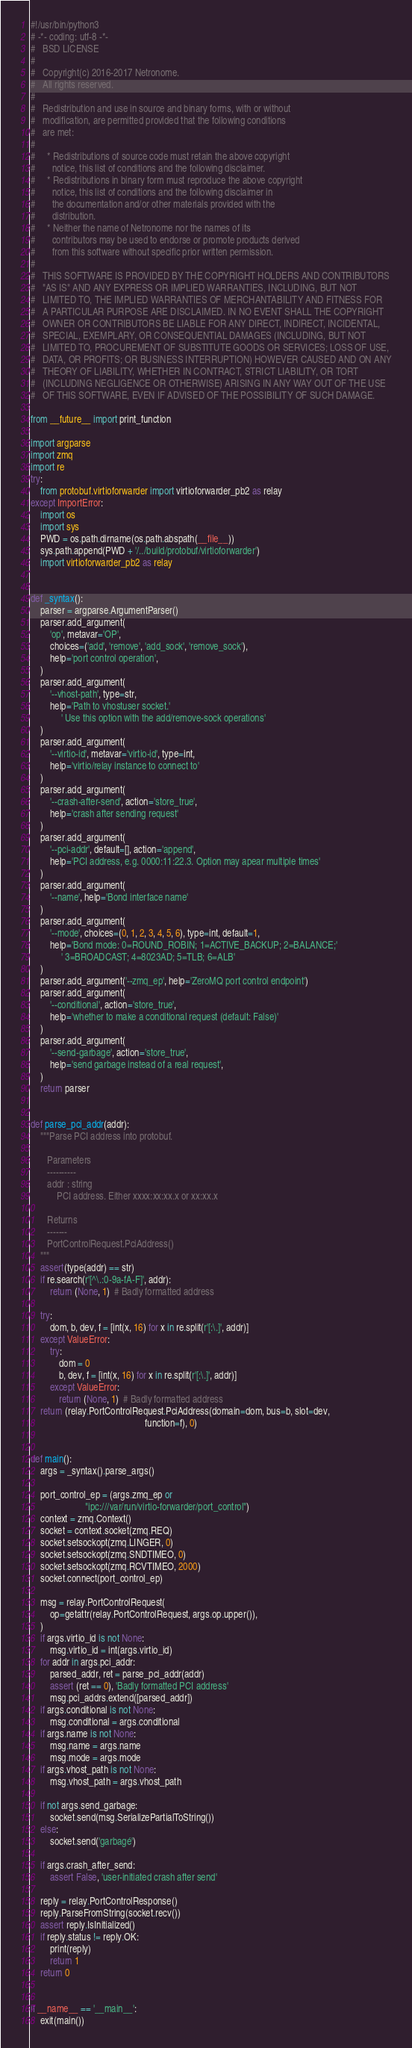Convert code to text. <code><loc_0><loc_0><loc_500><loc_500><_Python_>#!/usr/bin/python3
# -*- coding: utf-8 -*-
#   BSD LICENSE
#
#   Copyright(c) 2016-2017 Netronome.
#   All rights reserved.
#
#   Redistribution and use in source and binary forms, with or without
#   modification, are permitted provided that the following conditions
#   are met:
#
#     * Redistributions of source code must retain the above copyright
#       notice, this list of conditions and the following disclaimer.
#     * Redistributions in binary form must reproduce the above copyright
#       notice, this list of conditions and the following disclaimer in
#       the documentation and/or other materials provided with the
#       distribution.
#     * Neither the name of Netronome nor the names of its
#       contributors may be used to endorse or promote products derived
#       from this software without specific prior written permission.
#
#   THIS SOFTWARE IS PROVIDED BY THE COPYRIGHT HOLDERS AND CONTRIBUTORS
#   "AS IS" AND ANY EXPRESS OR IMPLIED WARRANTIES, INCLUDING, BUT NOT
#   LIMITED TO, THE IMPLIED WARRANTIES OF MERCHANTABILITY AND FITNESS FOR
#   A PARTICULAR PURPOSE ARE DISCLAIMED. IN NO EVENT SHALL THE COPYRIGHT
#   OWNER OR CONTRIBUTORS BE LIABLE FOR ANY DIRECT, INDIRECT, INCIDENTAL,
#   SPECIAL, EXEMPLARY, OR CONSEQUENTIAL DAMAGES (INCLUDING, BUT NOT
#   LIMITED TO, PROCUREMENT OF SUBSTITUTE GOODS OR SERVICES; LOSS OF USE,
#   DATA, OR PROFITS; OR BUSINESS INTERRUPTION) HOWEVER CAUSED AND ON ANY
#   THEORY OF LIABILITY, WHETHER IN CONTRACT, STRICT LIABILITY, OR TORT
#   (INCLUDING NEGLIGENCE OR OTHERWISE) ARISING IN ANY WAY OUT OF THE USE
#   OF THIS SOFTWARE, EVEN IF ADVISED OF THE POSSIBILITY OF SUCH DAMAGE.

from __future__ import print_function

import argparse
import zmq
import re
try:
    from protobuf.virtioforwarder import virtioforwarder_pb2 as relay
except ImportError:
    import os
    import sys
    PWD = os.path.dirname(os.path.abspath(__file__))
    sys.path.append(PWD + '/../build/protobuf/virtioforwarder')
    import virtioforwarder_pb2 as relay


def _syntax():
    parser = argparse.ArgumentParser()
    parser.add_argument(
        'op', metavar='OP',
        choices=('add', 'remove', 'add_sock', 'remove_sock'),
        help='port control operation',
    )
    parser.add_argument(
        '--vhost-path', type=str,
        help='Path to vhostuser socket.'
             ' Use this option with the add/remove-sock operations'
    )
    parser.add_argument(
        '--virtio-id', metavar='virtio-id', type=int,
        help='virtio/relay instance to connect to'
    )
    parser.add_argument(
        '--crash-after-send', action='store_true',
        help='crash after sending request'
    )
    parser.add_argument(
        '--pci-addr', default=[], action='append',
        help='PCI address, e.g. 0000:11:22.3. Option may apear multiple times'
    )
    parser.add_argument(
        '--name', help='Bond interface name'
    )
    parser.add_argument(
        '--mode', choices=(0, 1, 2, 3, 4, 5, 6), type=int, default=1,
        help='Bond mode: 0=ROUND_ROBIN; 1=ACTIVE_BACKUP; 2=BALANCE;'
             ' 3=BROADCAST; 4=8023AD; 5=TLB; 6=ALB'
    )
    parser.add_argument('--zmq_ep', help='ZeroMQ port control endpoint')
    parser.add_argument(
        '--conditional', action='store_true',
        help='whether to make a conditional request (default: False)'
    )
    parser.add_argument(
        '--send-garbage', action='store_true',
        help='send garbage instead of a real request',
    )
    return parser


def parse_pci_addr(addr):
    """Parse PCI address into protobuf.

       Parameters
       ----------
       addr : string
           PCI address. Either xxxx:xx:xx.x or xx:xx.x

       Returns
       -------
       PortControlRequest.PciAddress()
    """
    assert(type(addr) == str)
    if re.search(r'[^\.:0-9a-fA-F]', addr):
        return (None, 1)  # Badly formatted address

    try:
        dom, b, dev, f = [int(x, 16) for x in re.split(r'[:\.]', addr)]
    except ValueError:
        try:
            dom = 0
            b, dev, f = [int(x, 16) for x in re.split(r'[:\.]', addr)]
        except ValueError:
            return (None, 1)  # Badly formatted address
    return (relay.PortControlRequest.PciAddress(domain=dom, bus=b, slot=dev,
                                                function=f), 0)


def main():
    args = _syntax().parse_args()

    port_control_ep = (args.zmq_ep or
                       "ipc:///var/run/virtio-forwarder/port_control")
    context = zmq.Context()
    socket = context.socket(zmq.REQ)
    socket.setsockopt(zmq.LINGER, 0)
    socket.setsockopt(zmq.SNDTIMEO, 0)
    socket.setsockopt(zmq.RCVTIMEO, 2000)
    socket.connect(port_control_ep)

    msg = relay.PortControlRequest(
        op=getattr(relay.PortControlRequest, args.op.upper()),
    )
    if args.virtio_id is not None:
        msg.virtio_id = int(args.virtio_id)
    for addr in args.pci_addr:
        parsed_addr, ret = parse_pci_addr(addr)
        assert (ret == 0), 'Badly formatted PCI address'
        msg.pci_addrs.extend([parsed_addr])
    if args.conditional is not None:
        msg.conditional = args.conditional
    if args.name is not None:
        msg.name = args.name
        msg.mode = args.mode
    if args.vhost_path is not None:
        msg.vhost_path = args.vhost_path

    if not args.send_garbage:
        socket.send(msg.SerializePartialToString())
    else:
        socket.send('garbagé')

    if args.crash_after_send:
        assert False, 'user-initiated crash after send'

    reply = relay.PortControlResponse()
    reply.ParseFromString(socket.recv())
    assert reply.IsInitialized()
    if reply.status != reply.OK:
        print(reply)
        return 1
    return 0


if __name__ == '__main__':
    exit(main())
</code> 